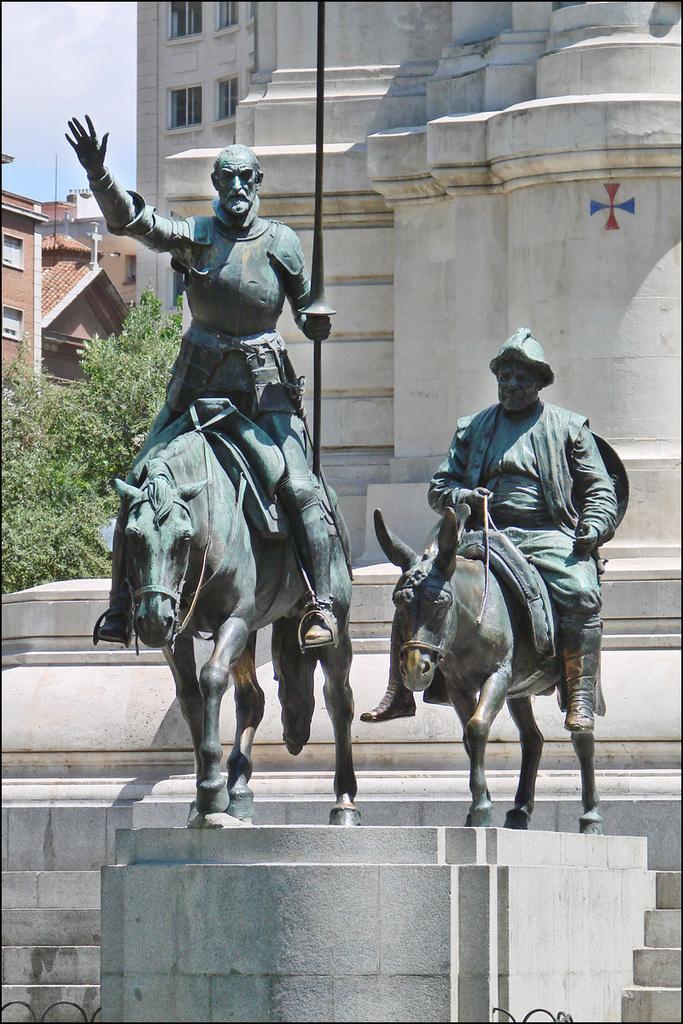How would you summarize this image in a sentence or two? In this image, we can see statues and in the background, there are buildings, trees and there are stairs. 